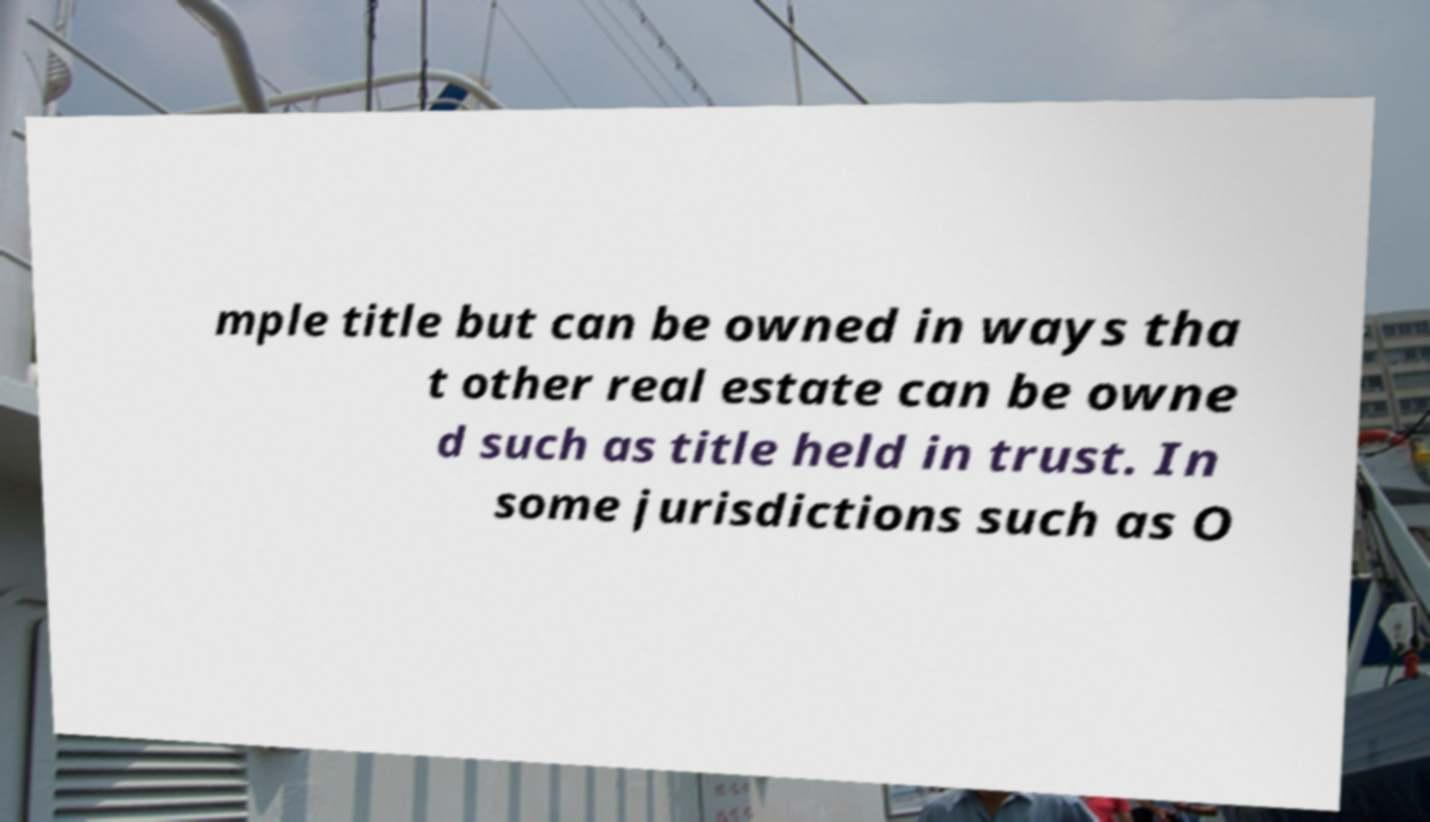Can you accurately transcribe the text from the provided image for me? mple title but can be owned in ways tha t other real estate can be owne d such as title held in trust. In some jurisdictions such as O 